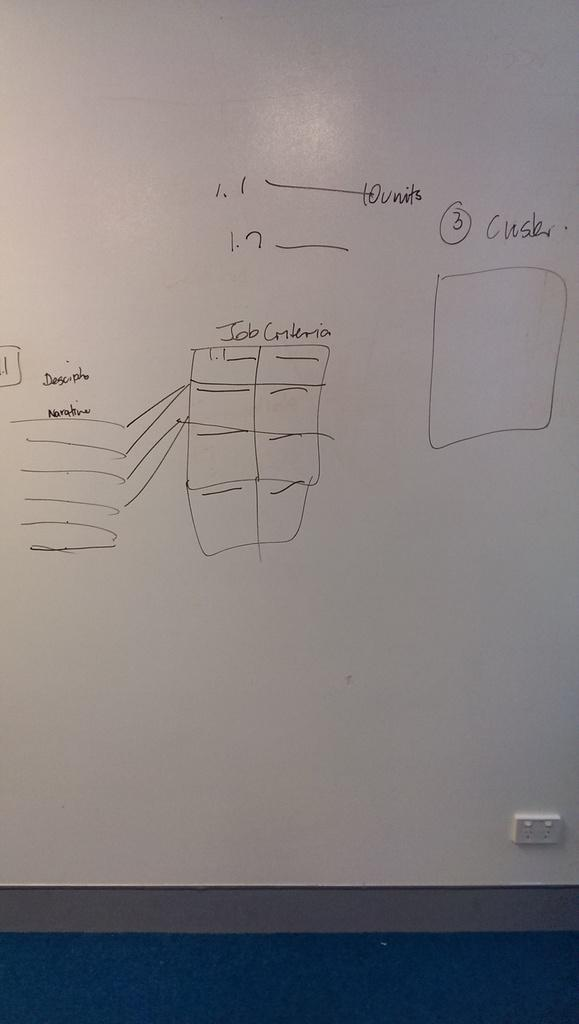<image>
Summarize the visual content of the image. A grid of boxes has the words "job criteria" over it. 